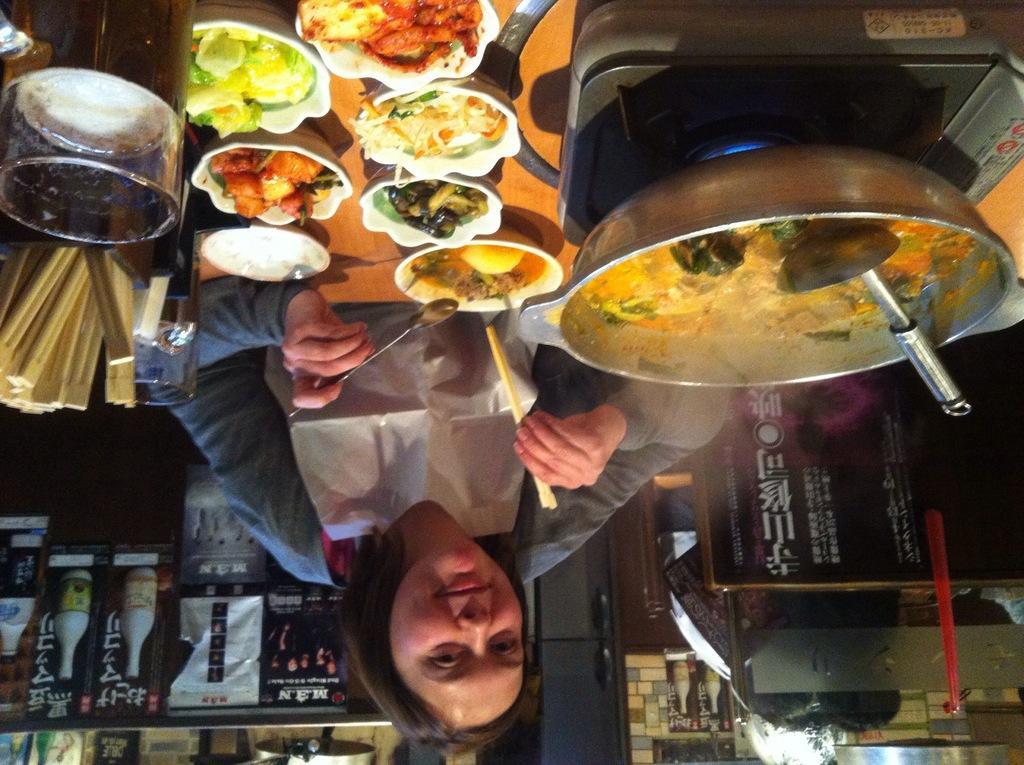Describe this image in one or two sentences. In this image there is a woman holding a spoon and a stick in her hand and in front of the woman there is food and in the background there are posters and there are objects. 